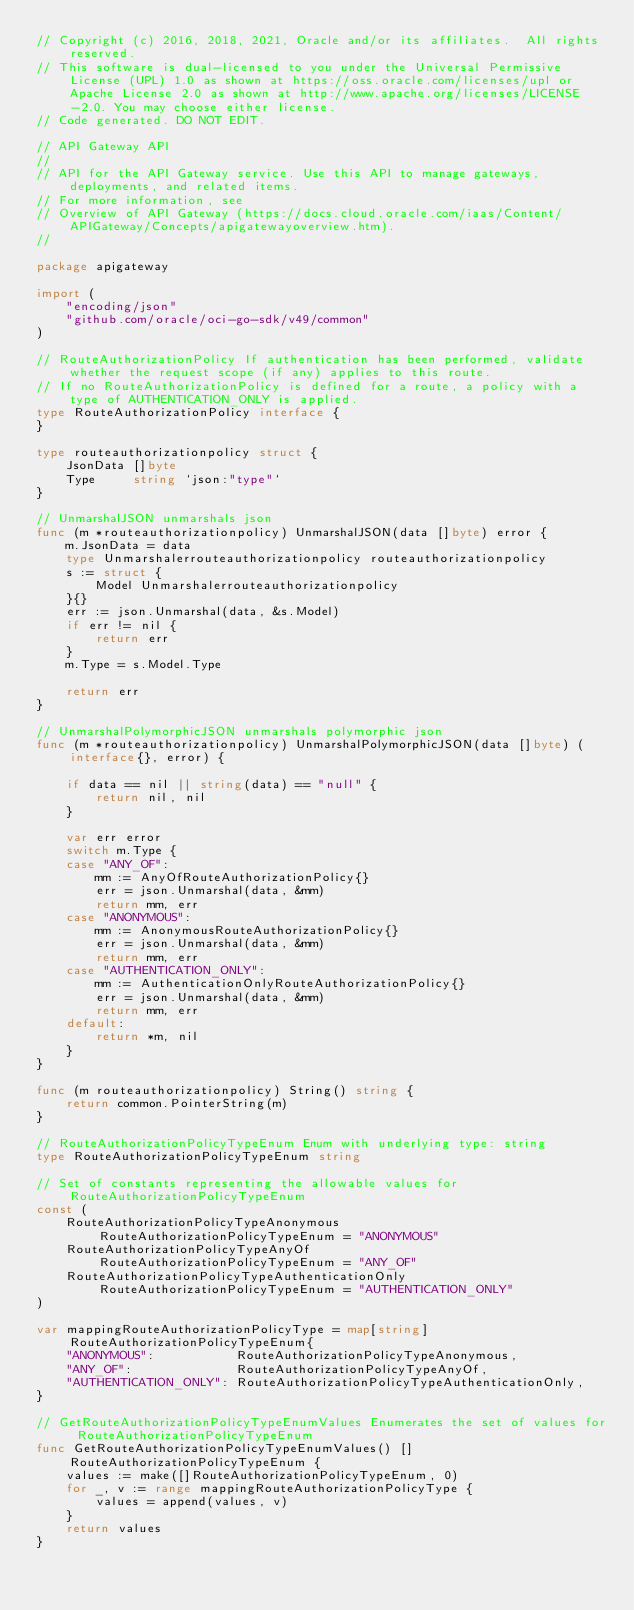Convert code to text. <code><loc_0><loc_0><loc_500><loc_500><_Go_>// Copyright (c) 2016, 2018, 2021, Oracle and/or its affiliates.  All rights reserved.
// This software is dual-licensed to you under the Universal Permissive License (UPL) 1.0 as shown at https://oss.oracle.com/licenses/upl or Apache License 2.0 as shown at http://www.apache.org/licenses/LICENSE-2.0. You may choose either license.
// Code generated. DO NOT EDIT.

// API Gateway API
//
// API for the API Gateway service. Use this API to manage gateways, deployments, and related items.
// For more information, see
// Overview of API Gateway (https://docs.cloud.oracle.com/iaas/Content/APIGateway/Concepts/apigatewayoverview.htm).
//

package apigateway

import (
	"encoding/json"
	"github.com/oracle/oci-go-sdk/v49/common"
)

// RouteAuthorizationPolicy If authentication has been performed, validate whether the request scope (if any) applies to this route.
// If no RouteAuthorizationPolicy is defined for a route, a policy with a type of AUTHENTICATION_ONLY is applied.
type RouteAuthorizationPolicy interface {
}

type routeauthorizationpolicy struct {
	JsonData []byte
	Type     string `json:"type"`
}

// UnmarshalJSON unmarshals json
func (m *routeauthorizationpolicy) UnmarshalJSON(data []byte) error {
	m.JsonData = data
	type Unmarshalerrouteauthorizationpolicy routeauthorizationpolicy
	s := struct {
		Model Unmarshalerrouteauthorizationpolicy
	}{}
	err := json.Unmarshal(data, &s.Model)
	if err != nil {
		return err
	}
	m.Type = s.Model.Type

	return err
}

// UnmarshalPolymorphicJSON unmarshals polymorphic json
func (m *routeauthorizationpolicy) UnmarshalPolymorphicJSON(data []byte) (interface{}, error) {

	if data == nil || string(data) == "null" {
		return nil, nil
	}

	var err error
	switch m.Type {
	case "ANY_OF":
		mm := AnyOfRouteAuthorizationPolicy{}
		err = json.Unmarshal(data, &mm)
		return mm, err
	case "ANONYMOUS":
		mm := AnonymousRouteAuthorizationPolicy{}
		err = json.Unmarshal(data, &mm)
		return mm, err
	case "AUTHENTICATION_ONLY":
		mm := AuthenticationOnlyRouteAuthorizationPolicy{}
		err = json.Unmarshal(data, &mm)
		return mm, err
	default:
		return *m, nil
	}
}

func (m routeauthorizationpolicy) String() string {
	return common.PointerString(m)
}

// RouteAuthorizationPolicyTypeEnum Enum with underlying type: string
type RouteAuthorizationPolicyTypeEnum string

// Set of constants representing the allowable values for RouteAuthorizationPolicyTypeEnum
const (
	RouteAuthorizationPolicyTypeAnonymous          RouteAuthorizationPolicyTypeEnum = "ANONYMOUS"
	RouteAuthorizationPolicyTypeAnyOf              RouteAuthorizationPolicyTypeEnum = "ANY_OF"
	RouteAuthorizationPolicyTypeAuthenticationOnly RouteAuthorizationPolicyTypeEnum = "AUTHENTICATION_ONLY"
)

var mappingRouteAuthorizationPolicyType = map[string]RouteAuthorizationPolicyTypeEnum{
	"ANONYMOUS":           RouteAuthorizationPolicyTypeAnonymous,
	"ANY_OF":              RouteAuthorizationPolicyTypeAnyOf,
	"AUTHENTICATION_ONLY": RouteAuthorizationPolicyTypeAuthenticationOnly,
}

// GetRouteAuthorizationPolicyTypeEnumValues Enumerates the set of values for RouteAuthorizationPolicyTypeEnum
func GetRouteAuthorizationPolicyTypeEnumValues() []RouteAuthorizationPolicyTypeEnum {
	values := make([]RouteAuthorizationPolicyTypeEnum, 0)
	for _, v := range mappingRouteAuthorizationPolicyType {
		values = append(values, v)
	}
	return values
}
</code> 